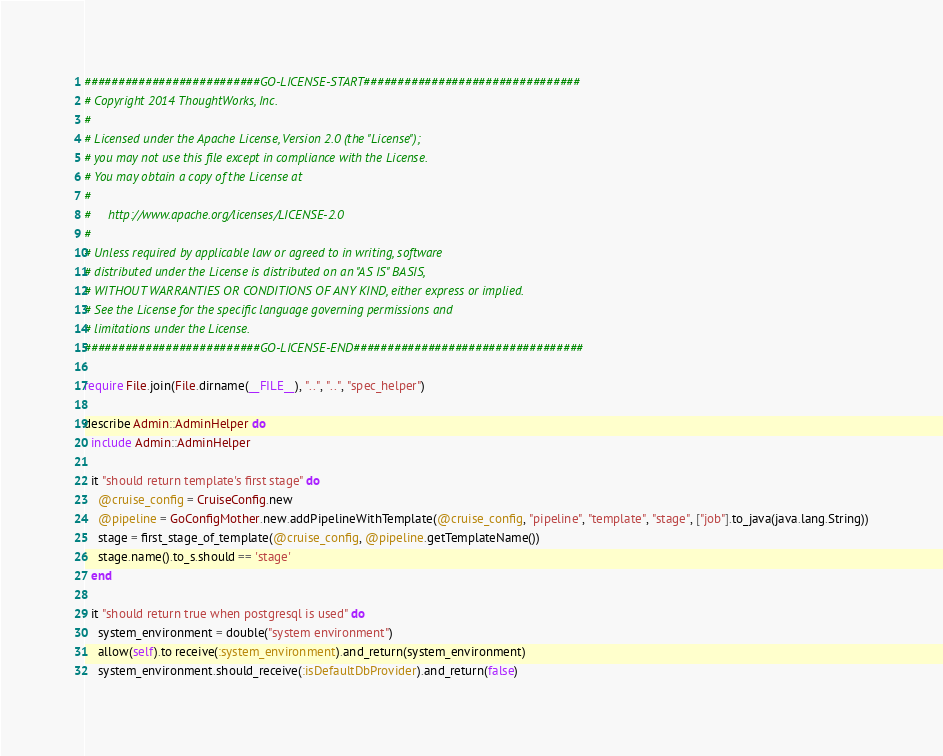<code> <loc_0><loc_0><loc_500><loc_500><_Ruby_>##########################GO-LICENSE-START################################
# Copyright 2014 ThoughtWorks, Inc.
#
# Licensed under the Apache License, Version 2.0 (the "License");
# you may not use this file except in compliance with the License.
# You may obtain a copy of the License at
#
#     http://www.apache.org/licenses/LICENSE-2.0
#
# Unless required by applicable law or agreed to in writing, software
# distributed under the License is distributed on an "AS IS" BASIS,
# WITHOUT WARRANTIES OR CONDITIONS OF ANY KIND, either express or implied.
# See the License for the specific language governing permissions and
# limitations under the License.
##########################GO-LICENSE-END##################################

require File.join(File.dirname(__FILE__), "..", "..", "spec_helper")

describe Admin::AdminHelper do
  include Admin::AdminHelper

  it "should return template's first stage" do
    @cruise_config = CruiseConfig.new
    @pipeline = GoConfigMother.new.addPipelineWithTemplate(@cruise_config, "pipeline", "template", "stage", ["job"].to_java(java.lang.String))
    stage = first_stage_of_template(@cruise_config, @pipeline.getTemplateName())
    stage.name().to_s.should == 'stage'
  end

  it "should return true when postgresql is used" do
    system_environment = double("system environment")
    allow(self).to receive(:system_environment).and_return(system_environment)
    system_environment.should_receive(:isDefaultDbProvider).and_return(false)</code> 